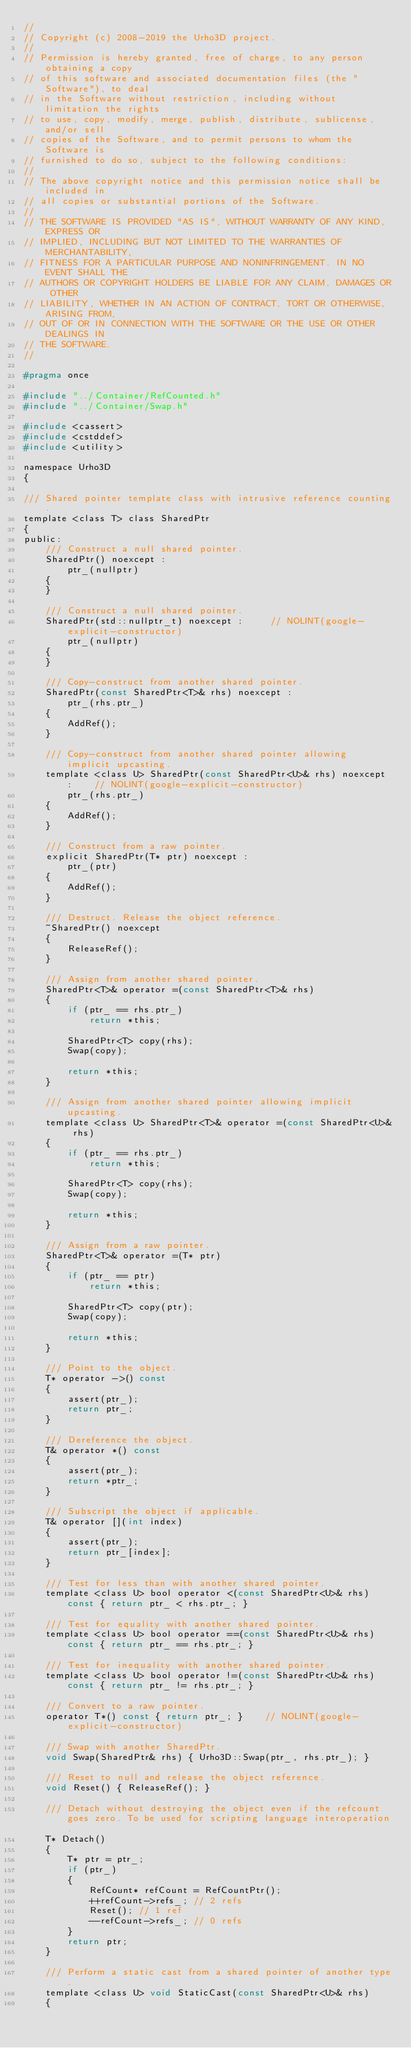<code> <loc_0><loc_0><loc_500><loc_500><_C_>//
// Copyright (c) 2008-2019 the Urho3D project.
//
// Permission is hereby granted, free of charge, to any person obtaining a copy
// of this software and associated documentation files (the "Software"), to deal
// in the Software without restriction, including without limitation the rights
// to use, copy, modify, merge, publish, distribute, sublicense, and/or sell
// copies of the Software, and to permit persons to whom the Software is
// furnished to do so, subject to the following conditions:
//
// The above copyright notice and this permission notice shall be included in
// all copies or substantial portions of the Software.
//
// THE SOFTWARE IS PROVIDED "AS IS", WITHOUT WARRANTY OF ANY KIND, EXPRESS OR
// IMPLIED, INCLUDING BUT NOT LIMITED TO THE WARRANTIES OF MERCHANTABILITY,
// FITNESS FOR A PARTICULAR PURPOSE AND NONINFRINGEMENT. IN NO EVENT SHALL THE
// AUTHORS OR COPYRIGHT HOLDERS BE LIABLE FOR ANY CLAIM, DAMAGES OR OTHER
// LIABILITY, WHETHER IN AN ACTION OF CONTRACT, TORT OR OTHERWISE, ARISING FROM,
// OUT OF OR IN CONNECTION WITH THE SOFTWARE OR THE USE OR OTHER DEALINGS IN
// THE SOFTWARE.
//

#pragma once

#include "../Container/RefCounted.h"
#include "../Container/Swap.h"

#include <cassert>
#include <cstddef>
#include <utility>

namespace Urho3D
{

/// Shared pointer template class with intrusive reference counting.
template <class T> class SharedPtr
{
public:
    /// Construct a null shared pointer.
    SharedPtr() noexcept :
        ptr_(nullptr)
    {
    }

    /// Construct a null shared pointer.
    SharedPtr(std::nullptr_t) noexcept :     // NOLINT(google-explicit-constructor)
        ptr_(nullptr)
    {
    }

    /// Copy-construct from another shared pointer.
    SharedPtr(const SharedPtr<T>& rhs) noexcept :
        ptr_(rhs.ptr_)
    {
        AddRef();
    }

    /// Copy-construct from another shared pointer allowing implicit upcasting.
    template <class U> SharedPtr(const SharedPtr<U>& rhs) noexcept :    // NOLINT(google-explicit-constructor)
        ptr_(rhs.ptr_)
    {
        AddRef();
    }

    /// Construct from a raw pointer.
    explicit SharedPtr(T* ptr) noexcept :
        ptr_(ptr)
    {
        AddRef();
    }

    /// Destruct. Release the object reference.
    ~SharedPtr() noexcept
    {
        ReleaseRef();
    }

    /// Assign from another shared pointer.
    SharedPtr<T>& operator =(const SharedPtr<T>& rhs)
    {
        if (ptr_ == rhs.ptr_)
            return *this;

        SharedPtr<T> copy(rhs);
        Swap(copy);

        return *this;
    }

    /// Assign from another shared pointer allowing implicit upcasting.
    template <class U> SharedPtr<T>& operator =(const SharedPtr<U>& rhs)
    {
        if (ptr_ == rhs.ptr_)
            return *this;

        SharedPtr<T> copy(rhs);
        Swap(copy);

        return *this;
    }

    /// Assign from a raw pointer.
    SharedPtr<T>& operator =(T* ptr)
    {
        if (ptr_ == ptr)
            return *this;

        SharedPtr<T> copy(ptr);
        Swap(copy);

        return *this;
    }

    /// Point to the object.
    T* operator ->() const
    {
        assert(ptr_);
        return ptr_;
    }

    /// Dereference the object.
    T& operator *() const
    {
        assert(ptr_);
        return *ptr_;
    }

    /// Subscript the object if applicable.
    T& operator [](int index)
    {
        assert(ptr_);
        return ptr_[index];
    }

    /// Test for less than with another shared pointer.
    template <class U> bool operator <(const SharedPtr<U>& rhs) const { return ptr_ < rhs.ptr_; }

    /// Test for equality with another shared pointer.
    template <class U> bool operator ==(const SharedPtr<U>& rhs) const { return ptr_ == rhs.ptr_; }

    /// Test for inequality with another shared pointer.
    template <class U> bool operator !=(const SharedPtr<U>& rhs) const { return ptr_ != rhs.ptr_; }

    /// Convert to a raw pointer.
    operator T*() const { return ptr_; }    // NOLINT(google-explicit-constructor)

    /// Swap with another SharedPtr.
    void Swap(SharedPtr& rhs) { Urho3D::Swap(ptr_, rhs.ptr_); }

    /// Reset to null and release the object reference.
    void Reset() { ReleaseRef(); }

    /// Detach without destroying the object even if the refcount goes zero. To be used for scripting language interoperation.
    T* Detach()
    {
        T* ptr = ptr_;
        if (ptr_)
        {
            RefCount* refCount = RefCountPtr();
            ++refCount->refs_; // 2 refs
            Reset(); // 1 ref
            --refCount->refs_; // 0 refs
        }
        return ptr;
    }

    /// Perform a static cast from a shared pointer of another type.
    template <class U> void StaticCast(const SharedPtr<U>& rhs)
    {</code> 